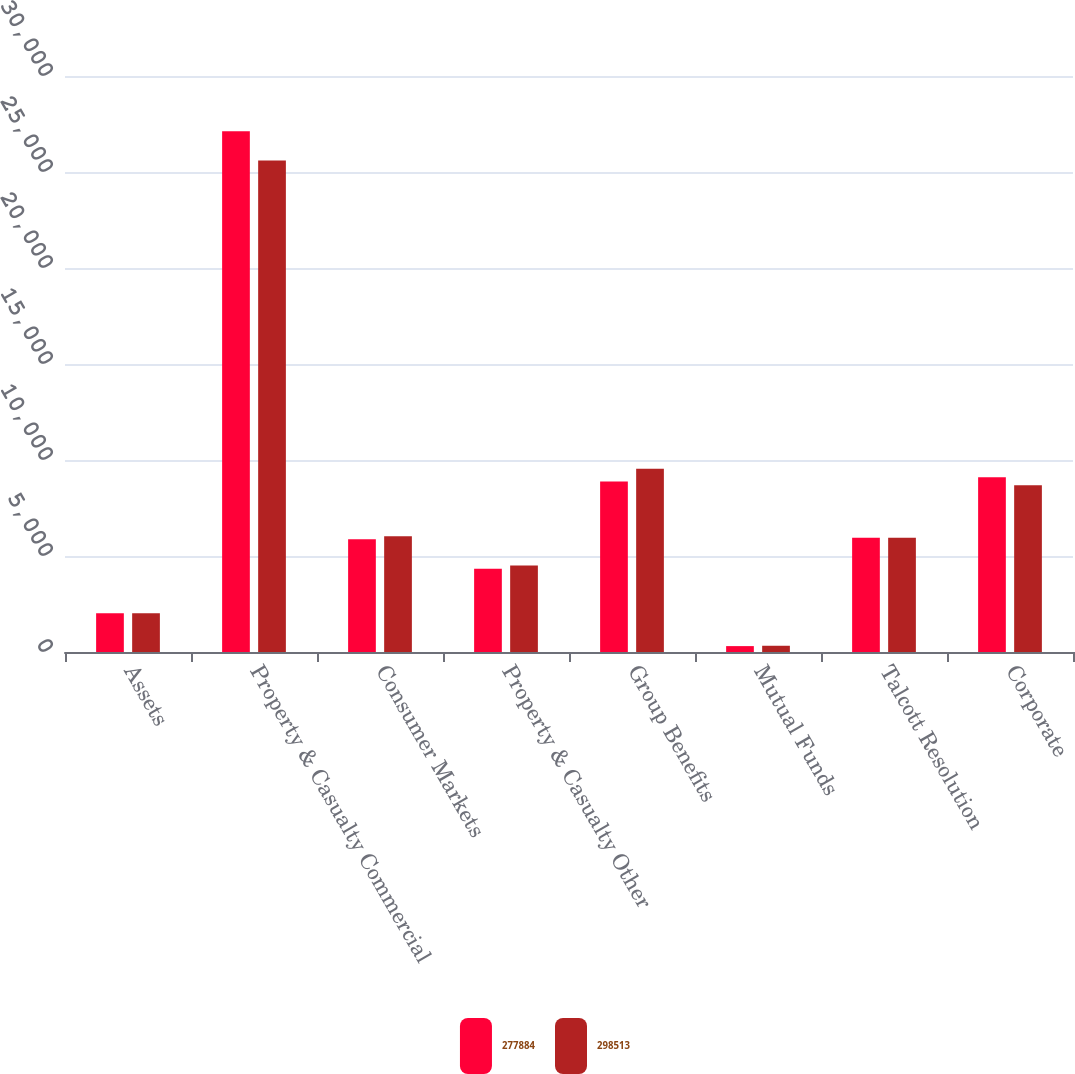Convert chart. <chart><loc_0><loc_0><loc_500><loc_500><stacked_bar_chart><ecel><fcel>Assets<fcel>Property & Casualty Commercial<fcel>Consumer Markets<fcel>Property & Casualty Other<fcel>Group Benefits<fcel>Mutual Funds<fcel>Talcott Resolution<fcel>Corporate<nl><fcel>277884<fcel>2013<fcel>27119<fcel>5873<fcel>4331<fcel>8882<fcel>307<fcel>5948.5<fcel>9103<nl><fcel>298513<fcel>2012<fcel>25595<fcel>6024<fcel>4509<fcel>9545<fcel>325<fcel>5948.5<fcel>8679<nl></chart> 